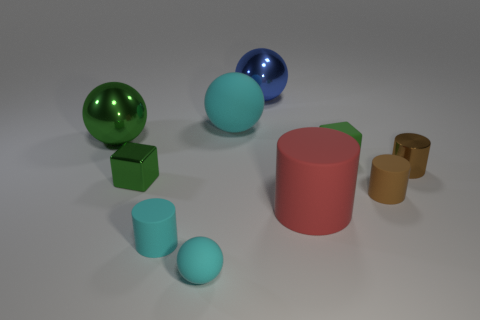Subtract 2 cubes. How many cubes are left? 0 Subtract all red cylinders. How many cylinders are left? 3 Subtract all large matte cylinders. How many cylinders are left? 3 Subtract 0 gray cubes. How many objects are left? 10 Subtract all cubes. How many objects are left? 8 Subtract all green spheres. Subtract all gray cylinders. How many spheres are left? 3 Subtract all yellow spheres. How many red cylinders are left? 1 Subtract all metallic cylinders. Subtract all tiny brown shiny cylinders. How many objects are left? 8 Add 2 big blue metal objects. How many big blue metal objects are left? 3 Add 2 red rubber cylinders. How many red rubber cylinders exist? 3 